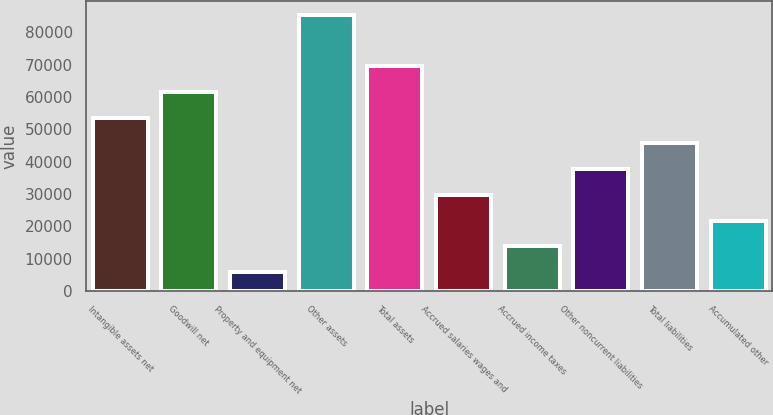<chart> <loc_0><loc_0><loc_500><loc_500><bar_chart><fcel>Intangible assets net<fcel>Goodwill net<fcel>Property and equipment net<fcel>Other assets<fcel>Total assets<fcel>Accrued salaries wages and<fcel>Accrued income taxes<fcel>Other noncurrent liabilities<fcel>Total liabilities<fcel>Accumulated other<nl><fcel>53638<fcel>61591.5<fcel>5917<fcel>85452<fcel>69545<fcel>29777.5<fcel>13870.5<fcel>37731<fcel>45684.5<fcel>21824<nl></chart> 